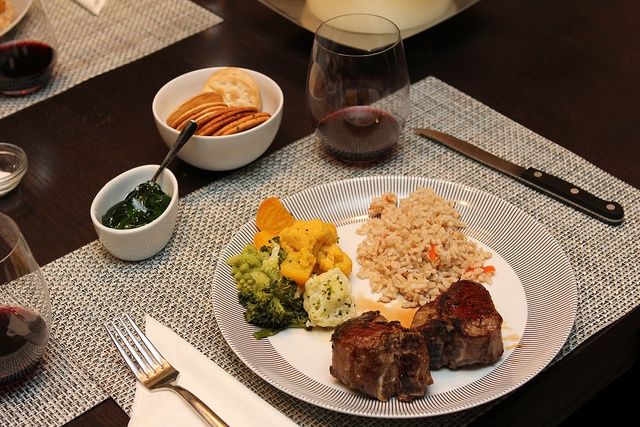Describe the objects in this image and their specific colors. I can see dining table in red, black, maroon, and tan tones, wine glass in red, black, maroon, gray, and tan tones, cup in red, black, maroon, gray, and tan tones, bowl in red, tan, and gray tones, and bowl in red, black, gray, and darkgray tones in this image. 